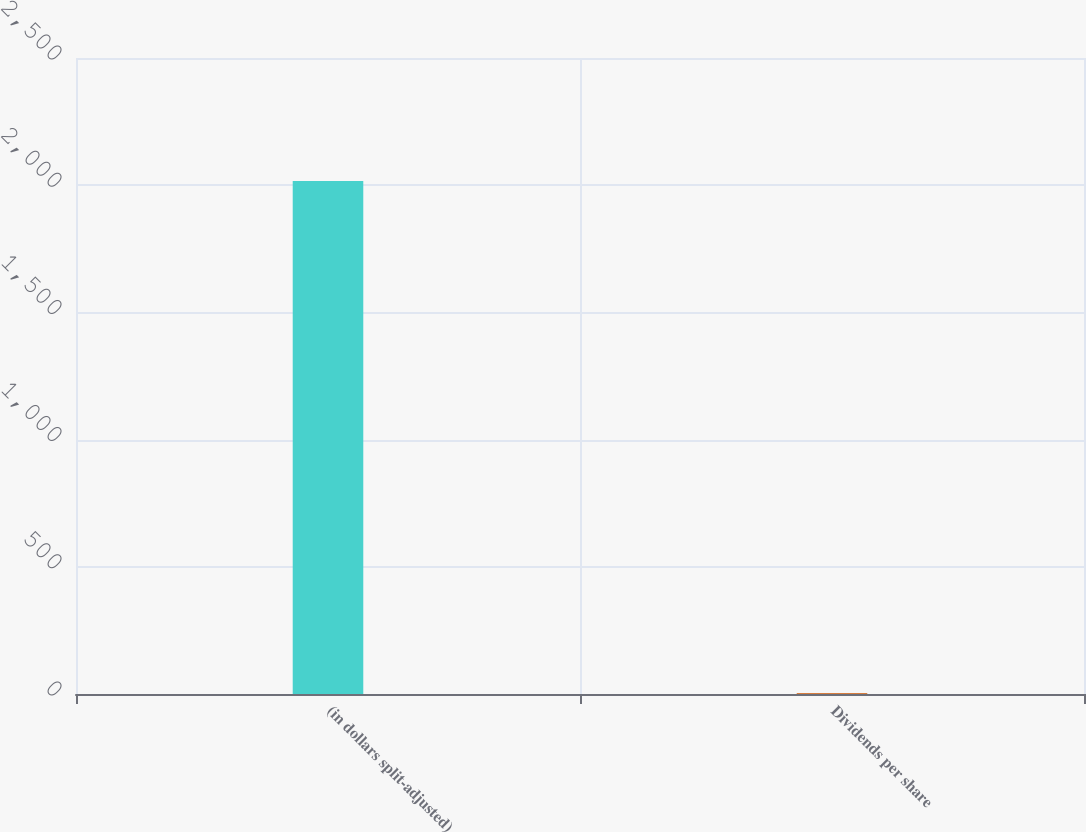Convert chart to OTSL. <chart><loc_0><loc_0><loc_500><loc_500><bar_chart><fcel>(in dollars split-adjusted)<fcel>Dividends per share<nl><fcel>2017<fcel>2.7<nl></chart> 